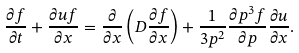<formula> <loc_0><loc_0><loc_500><loc_500>\frac { \partial { f } } { \partial { t } } + \frac { \partial { u f } } { \partial { x } } = \frac { \partial } { \partial { x } } \left ( D \frac { \partial { f } } { \partial { x } } \right ) + \frac { 1 } { 3 p ^ { 2 } } \frac { \partial { p ^ { 3 } f } } { \partial { p } } \frac { \partial { u } } { \partial { x } } .</formula> 